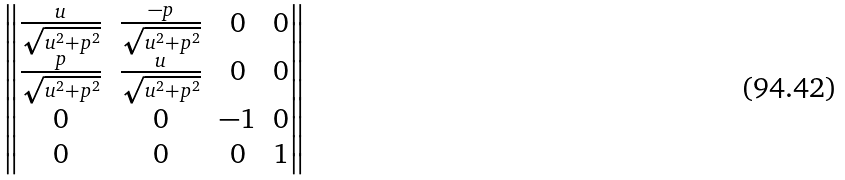Convert formula to latex. <formula><loc_0><loc_0><loc_500><loc_500>\begin{Vmatrix} \frac { u } { \sqrt { u ^ { 2 } + p ^ { 2 } } } & \frac { - p } { \sqrt { u ^ { 2 } + p ^ { 2 } } } & 0 & 0 \\ \frac { p } { \sqrt { u ^ { 2 } + p ^ { 2 } } } & \frac { u } { \sqrt { u ^ { 2 } + p ^ { 2 } } } & 0 & 0 \\ 0 & 0 & - 1 & 0 \\ 0 & 0 & 0 & 1 \end{Vmatrix}</formula> 